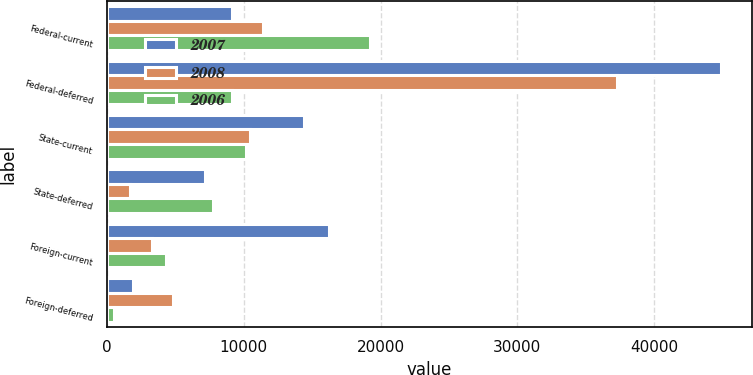Convert chart. <chart><loc_0><loc_0><loc_500><loc_500><stacked_bar_chart><ecel><fcel>Federal-current<fcel>Federal-deferred<fcel>State-current<fcel>State-deferred<fcel>Foreign-current<fcel>Foreign-deferred<nl><fcel>2007<fcel>9156<fcel>44862<fcel>14433<fcel>7143<fcel>16258<fcel>1943<nl><fcel>2008<fcel>11429<fcel>37301<fcel>10443<fcel>1683<fcel>3325<fcel>4829<nl><fcel>2006<fcel>19266<fcel>9156<fcel>10192<fcel>7777<fcel>4357<fcel>505<nl></chart> 